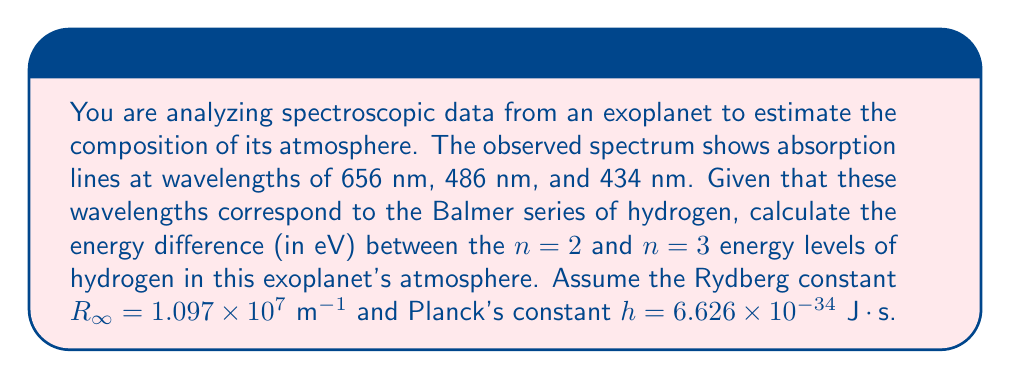Show me your answer to this math problem. Let's approach this step-by-step:

1) The Balmer series corresponds to electronic transitions from higher energy levels to the n=2 level in hydrogen. The wavelengths given correspond to transitions from n=3 to n=2 (656 nm), n=4 to n=2 (486 nm), and n=5 to n=2 (434 nm).

2) We'll focus on the transition from n=3 to n=2, which corresponds to the 656 nm line.

3) The energy of a photon is given by $E = hf = \frac{hc}{\lambda}$, where $f$ is frequency, $c$ is the speed of light, and $\lambda$ is wavelength.

4) We can calculate the energy difference using:

   $$\Delta E = E_3 - E_2 = \frac{hc}{\lambda}$$

5) Let's substitute the values:
   $h = 6.626 \times 10^{-34} \text{ J}\cdot\text{s}$
   $c = 3 \times 10^8 \text{ m/s}$
   $\lambda = 656 \times 10^{-9} \text{ m}$

6) Calculating:

   $$\Delta E = \frac{(6.626 \times 10^{-34})(3 \times 10^8)}{656 \times 10^{-9}} = 3.03 \times 10^{-19} \text{ J}$$

7) To convert from Joules to electron volts (eV), we divide by the charge of an electron ($1.602 \times 10^{-19} \text{ C}$):

   $$\Delta E = \frac{3.03 \times 10^{-19}}{1.602 \times 10^{-19}} = 1.89 \text{ eV}$$

Therefore, the energy difference between the n=2 and n=3 levels is approximately 1.89 eV.
Answer: 1.89 eV 